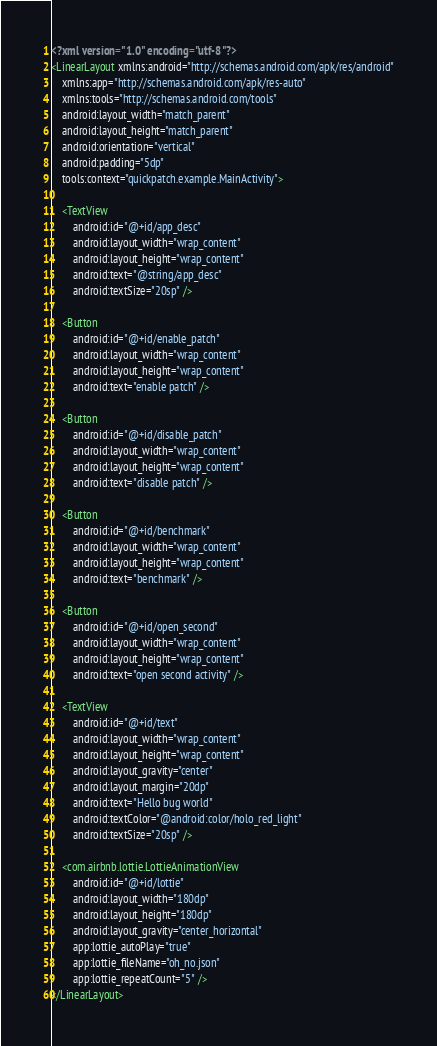Convert code to text. <code><loc_0><loc_0><loc_500><loc_500><_XML_><?xml version="1.0" encoding="utf-8"?>
<LinearLayout xmlns:android="http://schemas.android.com/apk/res/android"
    xmlns:app="http://schemas.android.com/apk/res-auto"
    xmlns:tools="http://schemas.android.com/tools"
    android:layout_width="match_parent"
    android:layout_height="match_parent"
    android:orientation="vertical"
    android:padding="5dp"
    tools:context="quickpatch.example.MainActivity">

    <TextView
        android:id="@+id/app_desc"
        android:layout_width="wrap_content"
        android:layout_height="wrap_content"
        android:text="@string/app_desc"
        android:textSize="20sp" />

    <Button
        android:id="@+id/enable_patch"
        android:layout_width="wrap_content"
        android:layout_height="wrap_content"
        android:text="enable patch" />

    <Button
        android:id="@+id/disable_patch"
        android:layout_width="wrap_content"
        android:layout_height="wrap_content"
        android:text="disable patch" />

    <Button
        android:id="@+id/benchmark"
        android:layout_width="wrap_content"
        android:layout_height="wrap_content"
        android:text="benchmark" />

    <Button
        android:id="@+id/open_second"
        android:layout_width="wrap_content"
        android:layout_height="wrap_content"
        android:text="open second activity" />

    <TextView
        android:id="@+id/text"
        android:layout_width="wrap_content"
        android:layout_height="wrap_content"
        android:layout_gravity="center"
        android:layout_margin="20dp"
        android:text="Hello bug world"
        android:textColor="@android:color/holo_red_light"
        android:textSize="20sp" />

    <com.airbnb.lottie.LottieAnimationView
        android:id="@+id/lottie"
        android:layout_width="180dp"
        android:layout_height="180dp"
        android:layout_gravity="center_horizontal"
        app:lottie_autoPlay="true"
        app:lottie_fileName="oh_no.json"
        app:lottie_repeatCount="5" />
</LinearLayout></code> 